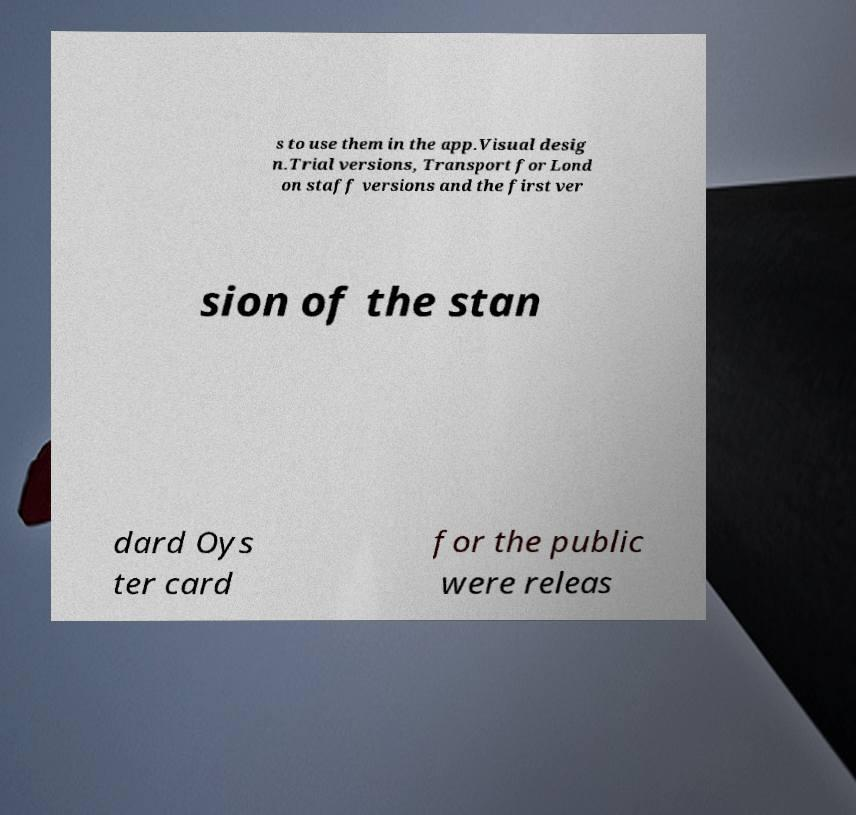Can you accurately transcribe the text from the provided image for me? s to use them in the app.Visual desig n.Trial versions, Transport for Lond on staff versions and the first ver sion of the stan dard Oys ter card for the public were releas 